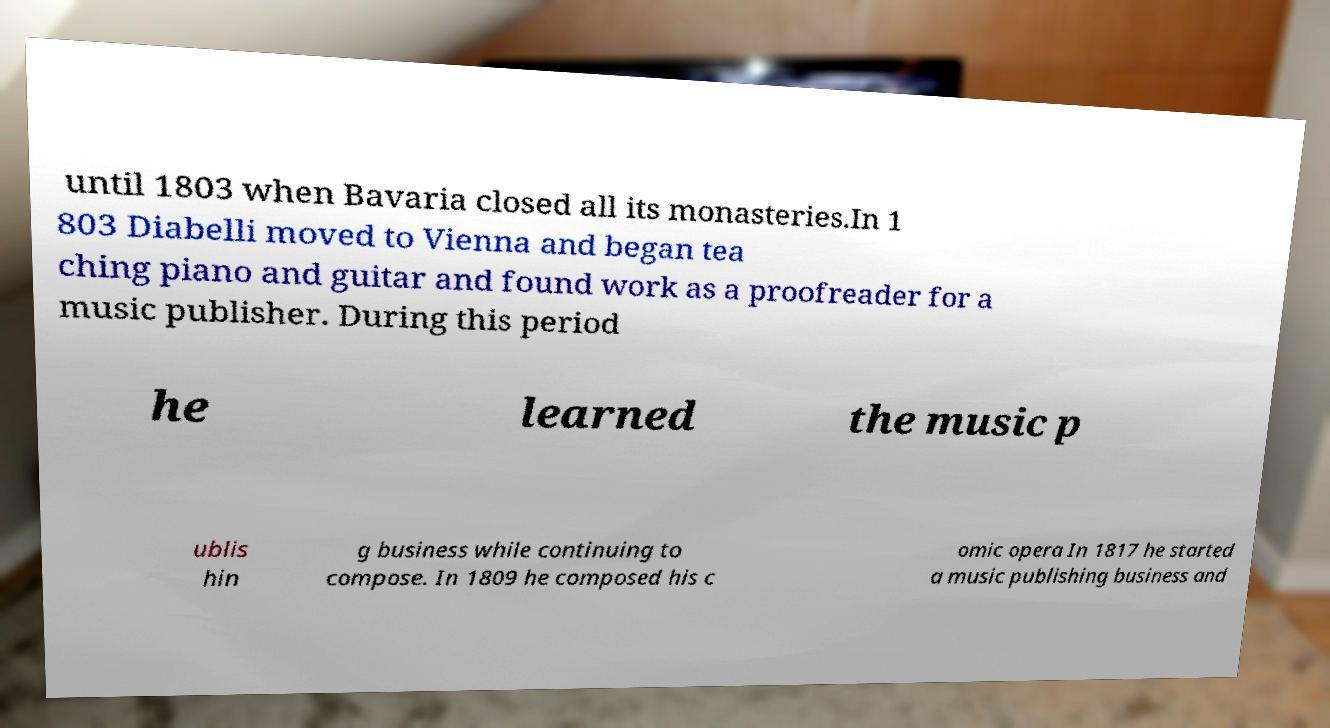Please identify and transcribe the text found in this image. until 1803 when Bavaria closed all its monasteries.In 1 803 Diabelli moved to Vienna and began tea ching piano and guitar and found work as a proofreader for a music publisher. During this period he learned the music p ublis hin g business while continuing to compose. In 1809 he composed his c omic opera In 1817 he started a music publishing business and 